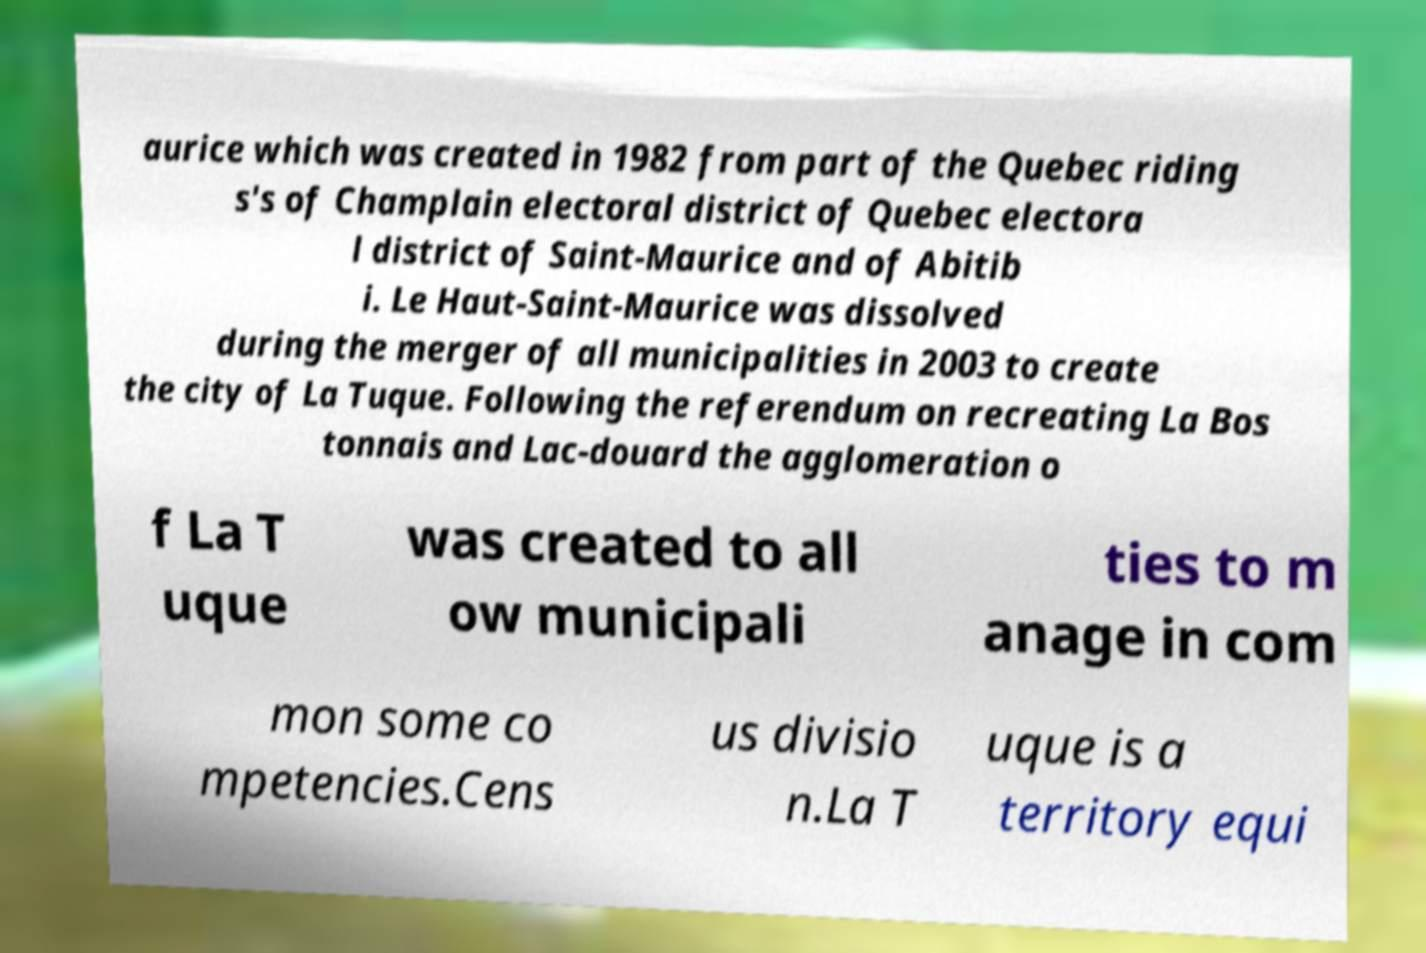Please identify and transcribe the text found in this image. aurice which was created in 1982 from part of the Quebec riding s's of Champlain electoral district of Quebec electora l district of Saint-Maurice and of Abitib i. Le Haut-Saint-Maurice was dissolved during the merger of all municipalities in 2003 to create the city of La Tuque. Following the referendum on recreating La Bos tonnais and Lac-douard the agglomeration o f La T uque was created to all ow municipali ties to m anage in com mon some co mpetencies.Cens us divisio n.La T uque is a territory equi 